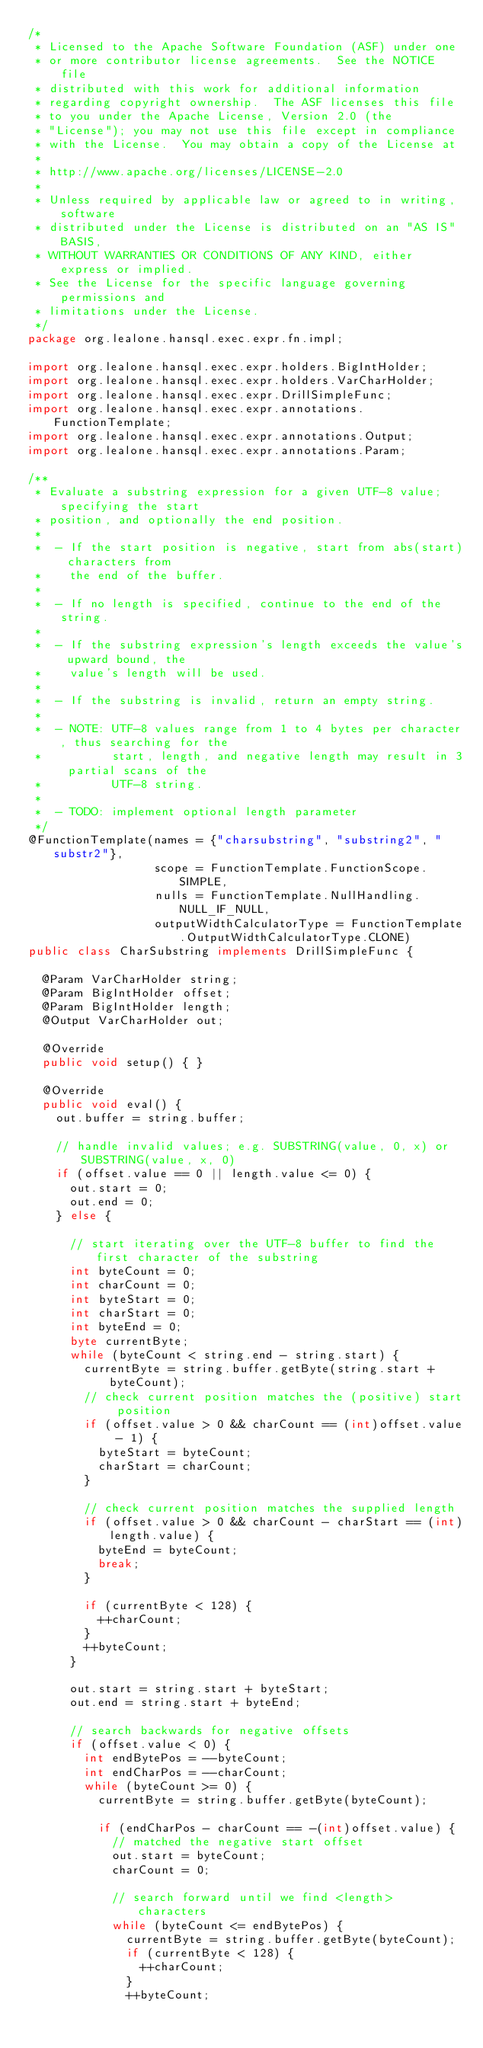<code> <loc_0><loc_0><loc_500><loc_500><_Java_>/*
 * Licensed to the Apache Software Foundation (ASF) under one
 * or more contributor license agreements.  See the NOTICE file
 * distributed with this work for additional information
 * regarding copyright ownership.  The ASF licenses this file
 * to you under the Apache License, Version 2.0 (the
 * "License"); you may not use this file except in compliance
 * with the License.  You may obtain a copy of the License at
 *
 * http://www.apache.org/licenses/LICENSE-2.0
 *
 * Unless required by applicable law or agreed to in writing, software
 * distributed under the License is distributed on an "AS IS" BASIS,
 * WITHOUT WARRANTIES OR CONDITIONS OF ANY KIND, either express or implied.
 * See the License for the specific language governing permissions and
 * limitations under the License.
 */
package org.lealone.hansql.exec.expr.fn.impl;

import org.lealone.hansql.exec.expr.holders.BigIntHolder;
import org.lealone.hansql.exec.expr.holders.VarCharHolder;
import org.lealone.hansql.exec.expr.DrillSimpleFunc;
import org.lealone.hansql.exec.expr.annotations.FunctionTemplate;
import org.lealone.hansql.exec.expr.annotations.Output;
import org.lealone.hansql.exec.expr.annotations.Param;

/**
 * Evaluate a substring expression for a given UTF-8 value; specifying the start
 * position, and optionally the end position.
 *
 *  - If the start position is negative, start from abs(start) characters from
 *    the end of the buffer.
 *
 *  - If no length is specified, continue to the end of the string.
 *
 *  - If the substring expression's length exceeds the value's upward bound, the
 *    value's length will be used.
 *
 *  - If the substring is invalid, return an empty string.
 *
 *  - NOTE: UTF-8 values range from 1 to 4 bytes per character, thus searching for the
 *          start, length, and negative length may result in 3 partial scans of the
 *          UTF-8 string.
 *
 *  - TODO: implement optional length parameter
 */
@FunctionTemplate(names = {"charsubstring", "substring2", "substr2"},
                  scope = FunctionTemplate.FunctionScope.SIMPLE,
                  nulls = FunctionTemplate.NullHandling.NULL_IF_NULL,
                  outputWidthCalculatorType = FunctionTemplate.OutputWidthCalculatorType.CLONE)
public class CharSubstring implements DrillSimpleFunc {

  @Param VarCharHolder string;
  @Param BigIntHolder offset;
  @Param BigIntHolder length;
  @Output VarCharHolder out;

  @Override
  public void setup() { }

  @Override
  public void eval() {
    out.buffer = string.buffer;

    // handle invalid values; e.g. SUBSTRING(value, 0, x) or SUBSTRING(value, x, 0)
    if (offset.value == 0 || length.value <= 0) {
      out.start = 0;
      out.end = 0;
    } else {

      // start iterating over the UTF-8 buffer to find the first character of the substring
      int byteCount = 0;
      int charCount = 0;
      int byteStart = 0;
      int charStart = 0;
      int byteEnd = 0;
      byte currentByte;
      while (byteCount < string.end - string.start) {
        currentByte = string.buffer.getByte(string.start + byteCount);
        // check current position matches the (positive) start position
        if (offset.value > 0 && charCount == (int)offset.value - 1) {
          byteStart = byteCount;
          charStart = charCount;
        }

        // check current position matches the supplied length
        if (offset.value > 0 && charCount - charStart == (int)length.value) {
          byteEnd = byteCount;
          break;
        }

        if (currentByte < 128) {
          ++charCount;
        }
        ++byteCount;
      }

      out.start = string.start + byteStart;
      out.end = string.start + byteEnd;

      // search backwards for negative offsets
      if (offset.value < 0) {
        int endBytePos = --byteCount;
        int endCharPos = --charCount;
        while (byteCount >= 0) {
          currentByte = string.buffer.getByte(byteCount);

          if (endCharPos - charCount == -(int)offset.value) {
            // matched the negative start offset
            out.start = byteCount;
            charCount = 0;

            // search forward until we find <length> characters
            while (byteCount <= endBytePos) {
              currentByte = string.buffer.getByte(byteCount);
              if (currentByte < 128) {
                ++charCount;
              }
              ++byteCount;</code> 